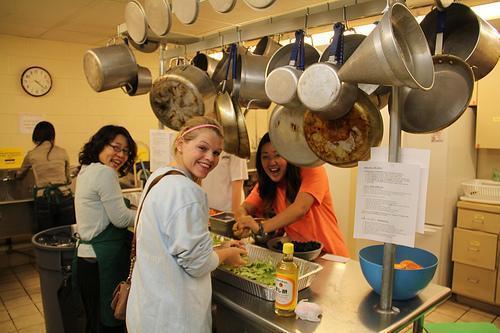How many people are there?
Give a very brief answer. 4. 